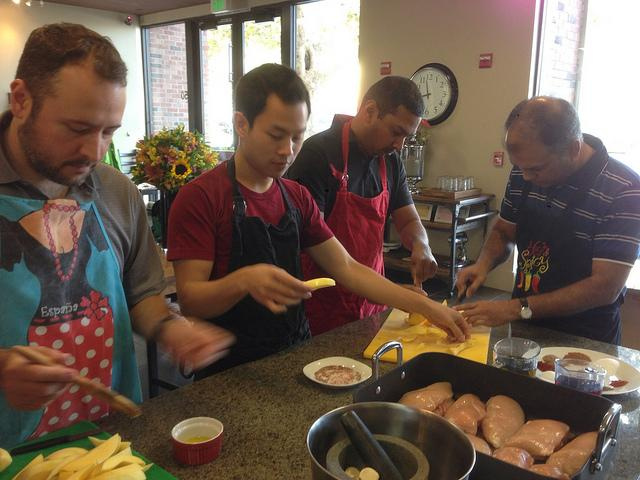What do these people do here? Please explain your reasoning. cook. The people are visibly preparing food and putting them in vessels that would be used for the purposes of answer a. 